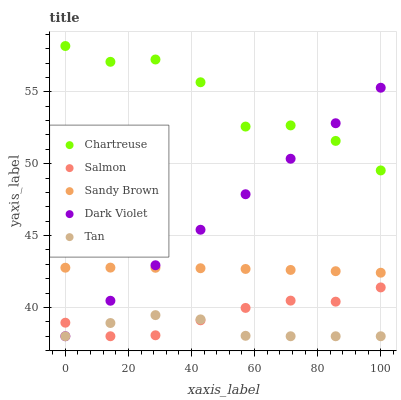Does Tan have the minimum area under the curve?
Answer yes or no. Yes. Does Chartreuse have the maximum area under the curve?
Answer yes or no. Yes. Does Salmon have the minimum area under the curve?
Answer yes or no. No. Does Salmon have the maximum area under the curve?
Answer yes or no. No. Is Dark Violet the smoothest?
Answer yes or no. Yes. Is Chartreuse the roughest?
Answer yes or no. Yes. Is Salmon the smoothest?
Answer yes or no. No. Is Salmon the roughest?
Answer yes or no. No. Does Salmon have the lowest value?
Answer yes or no. Yes. Does Chartreuse have the lowest value?
Answer yes or no. No. Does Chartreuse have the highest value?
Answer yes or no. Yes. Does Salmon have the highest value?
Answer yes or no. No. Is Salmon less than Sandy Brown?
Answer yes or no. Yes. Is Chartreuse greater than Tan?
Answer yes or no. Yes. Does Salmon intersect Dark Violet?
Answer yes or no. Yes. Is Salmon less than Dark Violet?
Answer yes or no. No. Is Salmon greater than Dark Violet?
Answer yes or no. No. Does Salmon intersect Sandy Brown?
Answer yes or no. No. 